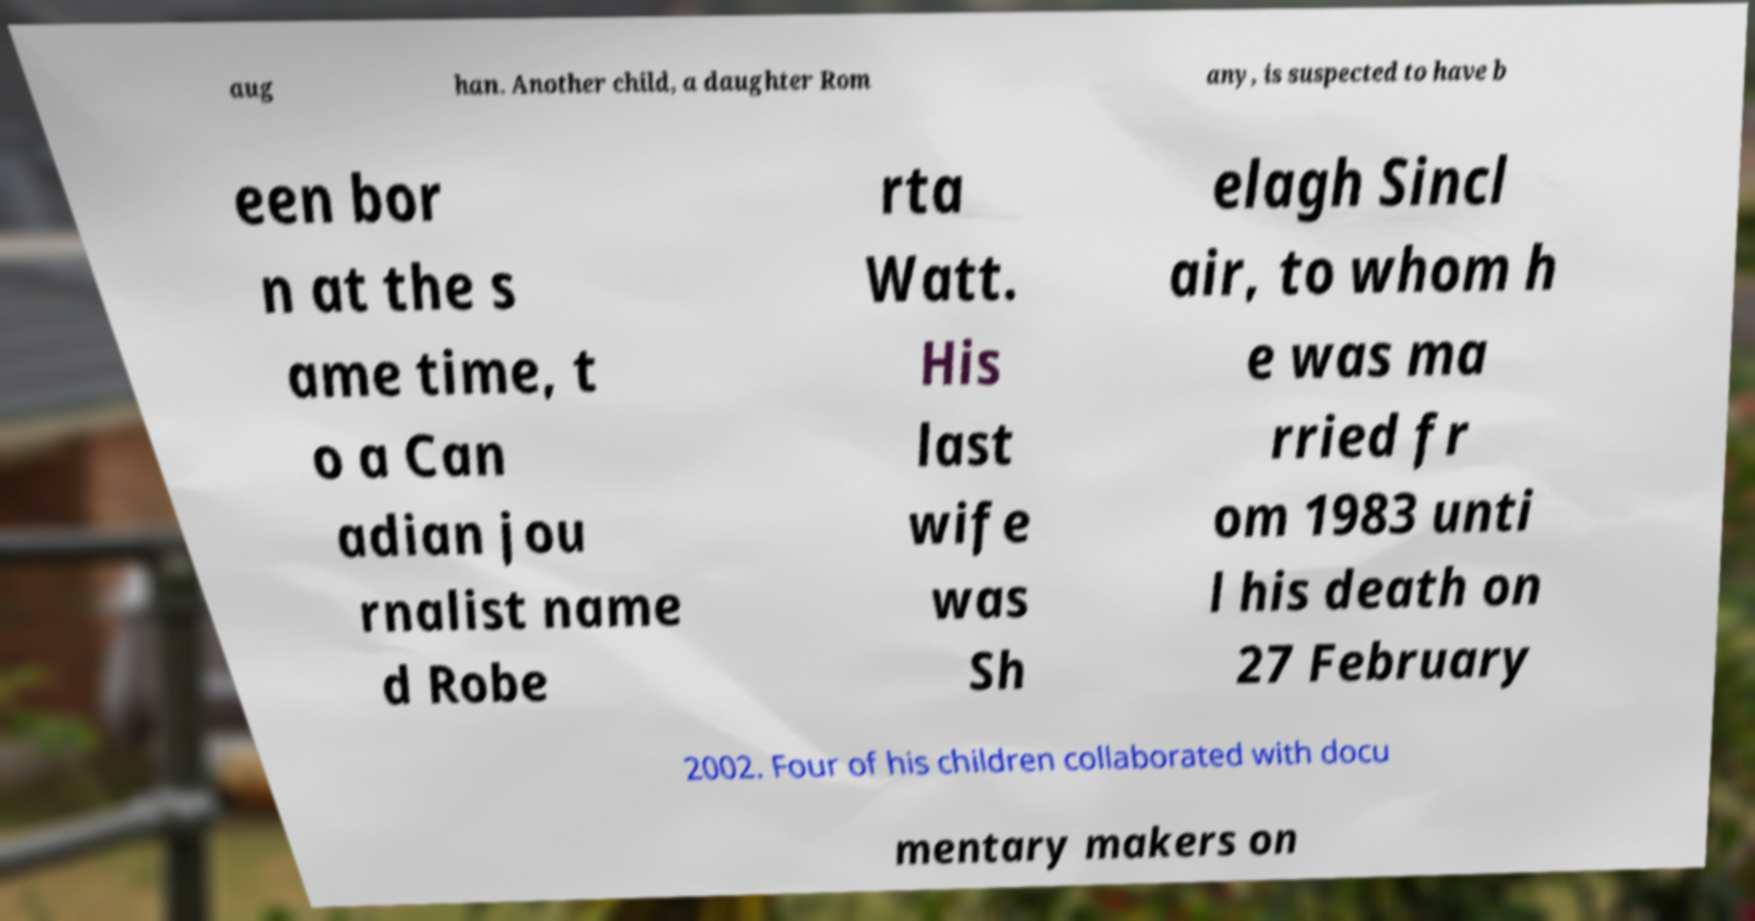Please read and relay the text visible in this image. What does it say? aug han. Another child, a daughter Rom any, is suspected to have b een bor n at the s ame time, t o a Can adian jou rnalist name d Robe rta Watt. His last wife was Sh elagh Sincl air, to whom h e was ma rried fr om 1983 unti l his death on 27 February 2002. Four of his children collaborated with docu mentary makers on 